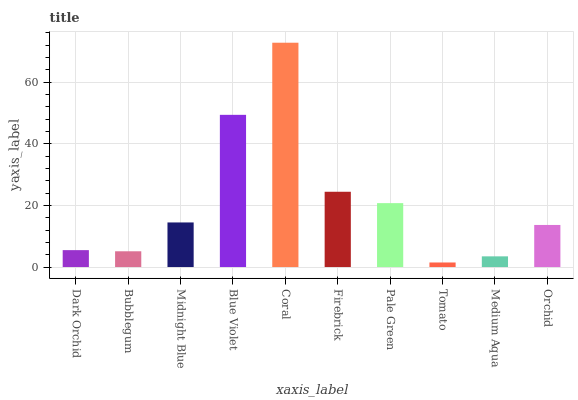Is Tomato the minimum?
Answer yes or no. Yes. Is Coral the maximum?
Answer yes or no. Yes. Is Bubblegum the minimum?
Answer yes or no. No. Is Bubblegum the maximum?
Answer yes or no. No. Is Dark Orchid greater than Bubblegum?
Answer yes or no. Yes. Is Bubblegum less than Dark Orchid?
Answer yes or no. Yes. Is Bubblegum greater than Dark Orchid?
Answer yes or no. No. Is Dark Orchid less than Bubblegum?
Answer yes or no. No. Is Midnight Blue the high median?
Answer yes or no. Yes. Is Orchid the low median?
Answer yes or no. Yes. Is Dark Orchid the high median?
Answer yes or no. No. Is Medium Aqua the low median?
Answer yes or no. No. 